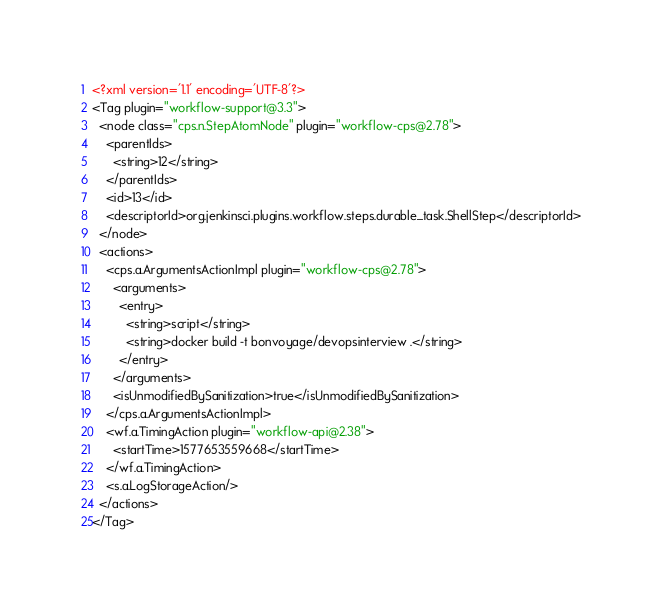<code> <loc_0><loc_0><loc_500><loc_500><_XML_><?xml version='1.1' encoding='UTF-8'?>
<Tag plugin="workflow-support@3.3">
  <node class="cps.n.StepAtomNode" plugin="workflow-cps@2.78">
    <parentIds>
      <string>12</string>
    </parentIds>
    <id>13</id>
    <descriptorId>org.jenkinsci.plugins.workflow.steps.durable_task.ShellStep</descriptorId>
  </node>
  <actions>
    <cps.a.ArgumentsActionImpl plugin="workflow-cps@2.78">
      <arguments>
        <entry>
          <string>script</string>
          <string>docker build -t bonvoyage/devopsinterview .</string>
        </entry>
      </arguments>
      <isUnmodifiedBySanitization>true</isUnmodifiedBySanitization>
    </cps.a.ArgumentsActionImpl>
    <wf.a.TimingAction plugin="workflow-api@2.38">
      <startTime>1577653559668</startTime>
    </wf.a.TimingAction>
    <s.a.LogStorageAction/>
  </actions>
</Tag></code> 